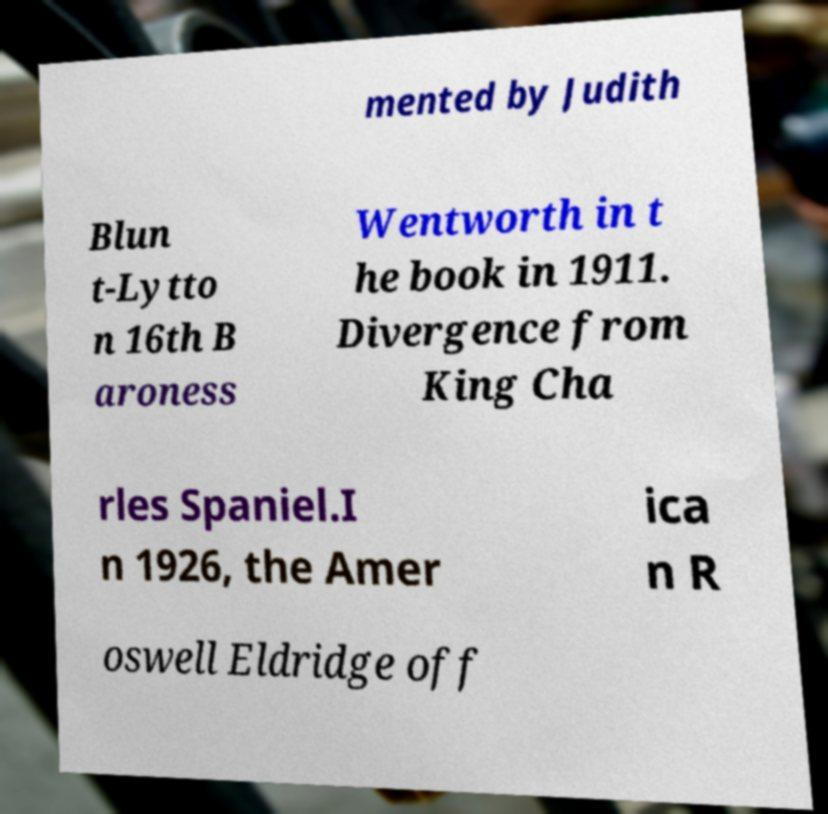What messages or text are displayed in this image? I need them in a readable, typed format. mented by Judith Blun t-Lytto n 16th B aroness Wentworth in t he book in 1911. Divergence from King Cha rles Spaniel.I n 1926, the Amer ica n R oswell Eldridge off 